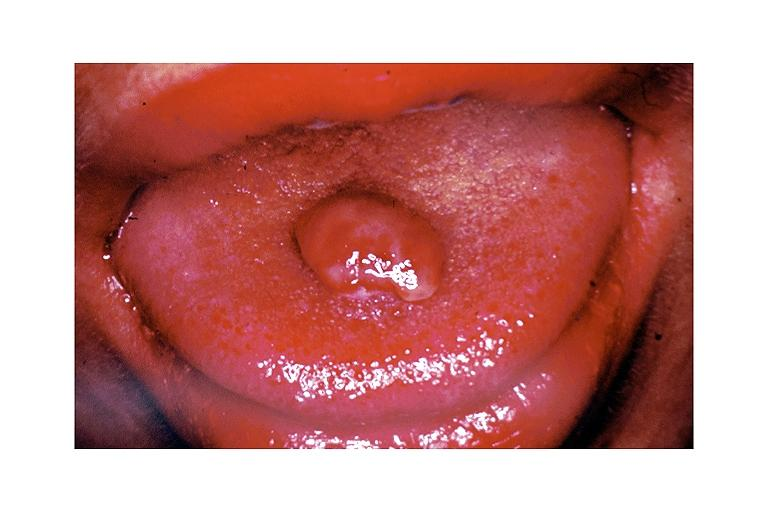what does this image show?
Answer the question using a single word or phrase. Pyogenic granuloma 